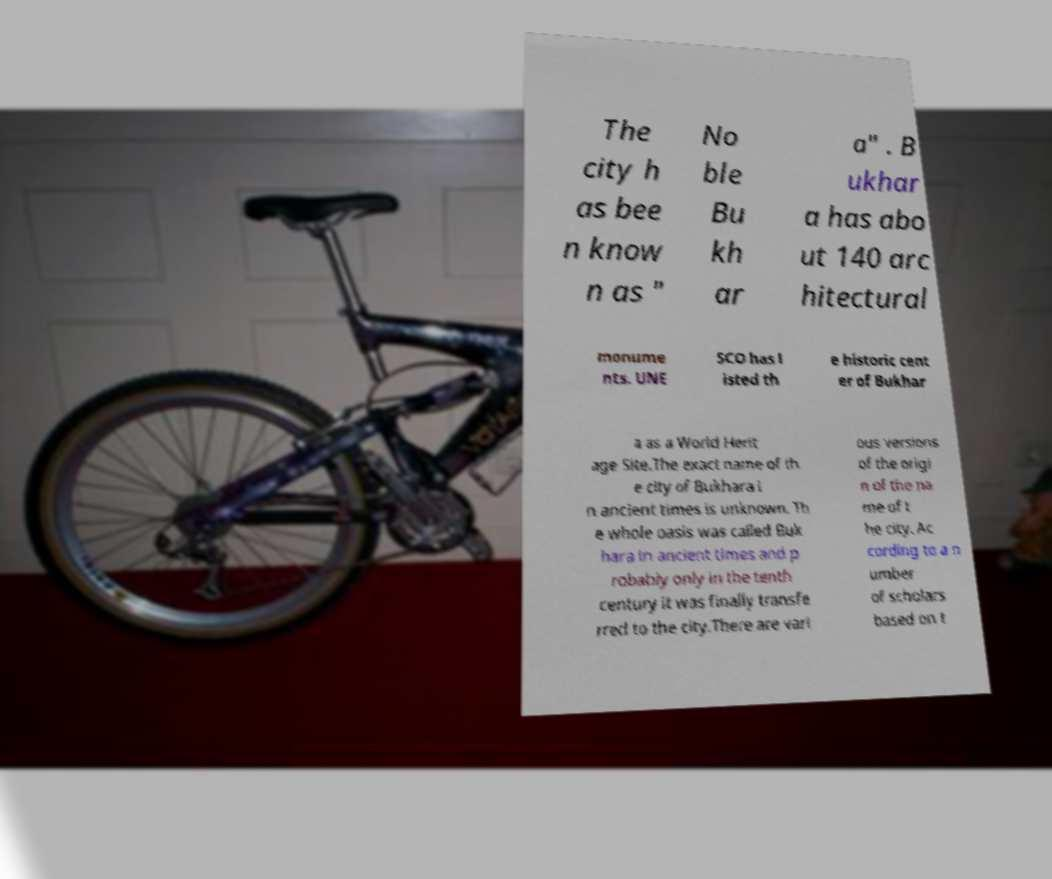There's text embedded in this image that I need extracted. Can you transcribe it verbatim? The city h as bee n know n as " No ble Bu kh ar a" . B ukhar a has abo ut 140 arc hitectural monume nts. UNE SCO has l isted th e historic cent er of Bukhar a as a World Herit age Site.The exact name of th e city of Bukhara i n ancient times is unknown. Th e whole oasis was called Buk hara in ancient times and p robably only in the tenth century it was finally transfe rred to the city.There are vari ous versions of the origi n of the na me of t he city. Ac cording to a n umber of scholars based on t 